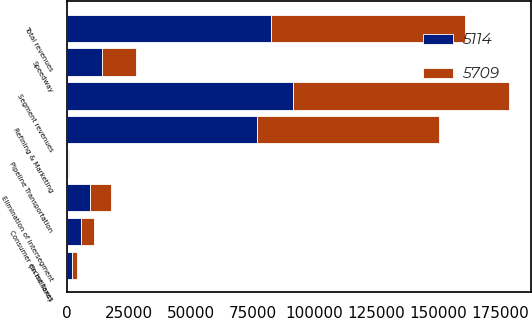Convert chart. <chart><loc_0><loc_0><loc_500><loc_500><stacked_bar_chart><ecel><fcel>(In millions)<fcel>Refining & Marketing<fcel>Speedway<fcel>Pipeline Transportation<fcel>Segment revenues<fcel>Elimination of intersegment<fcel>Total revenues<fcel>Consumer excise taxes<nl><fcel>5114<fcel>2012<fcel>76710<fcel>14243<fcel>459<fcel>91412<fcel>9167<fcel>82245<fcel>5709<nl><fcel>5709<fcel>2011<fcel>73381<fcel>13490<fcel>403<fcel>87274<fcel>8636<fcel>78638<fcel>5114<nl></chart> 